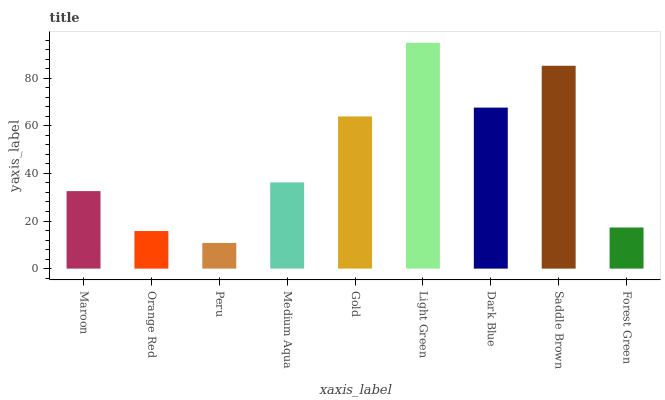Is Peru the minimum?
Answer yes or no. Yes. Is Light Green the maximum?
Answer yes or no. Yes. Is Orange Red the minimum?
Answer yes or no. No. Is Orange Red the maximum?
Answer yes or no. No. Is Maroon greater than Orange Red?
Answer yes or no. Yes. Is Orange Red less than Maroon?
Answer yes or no. Yes. Is Orange Red greater than Maroon?
Answer yes or no. No. Is Maroon less than Orange Red?
Answer yes or no. No. Is Medium Aqua the high median?
Answer yes or no. Yes. Is Medium Aqua the low median?
Answer yes or no. Yes. Is Saddle Brown the high median?
Answer yes or no. No. Is Saddle Brown the low median?
Answer yes or no. No. 